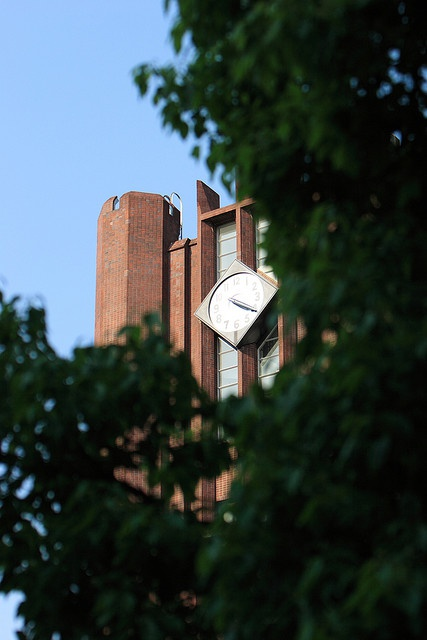Describe the objects in this image and their specific colors. I can see a clock in lightblue, white, darkgray, gray, and black tones in this image. 